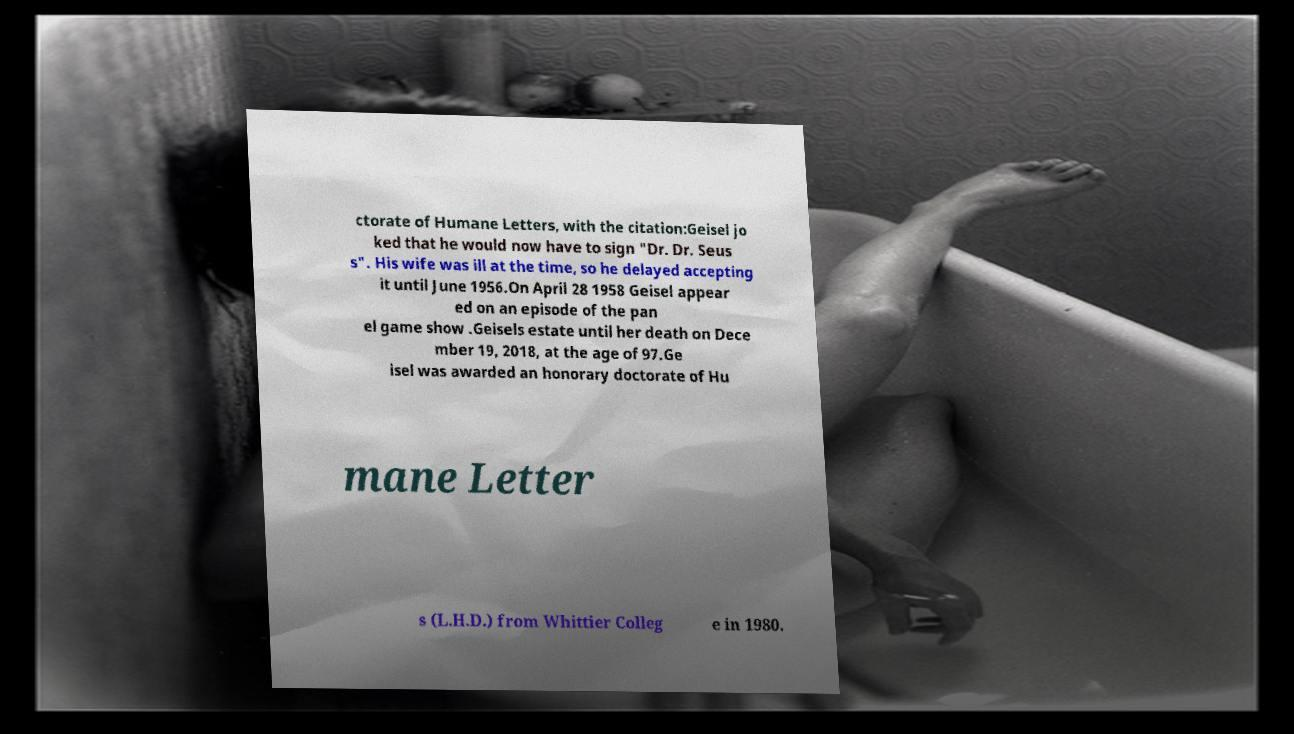Can you read and provide the text displayed in the image?This photo seems to have some interesting text. Can you extract and type it out for me? ctorate of Humane Letters, with the citation:Geisel jo ked that he would now have to sign "Dr. Dr. Seus s". His wife was ill at the time, so he delayed accepting it until June 1956.On April 28 1958 Geisel appear ed on an episode of the pan el game show .Geisels estate until her death on Dece mber 19, 2018, at the age of 97.Ge isel was awarded an honorary doctorate of Hu mane Letter s (L.H.D.) from Whittier Colleg e in 1980. 